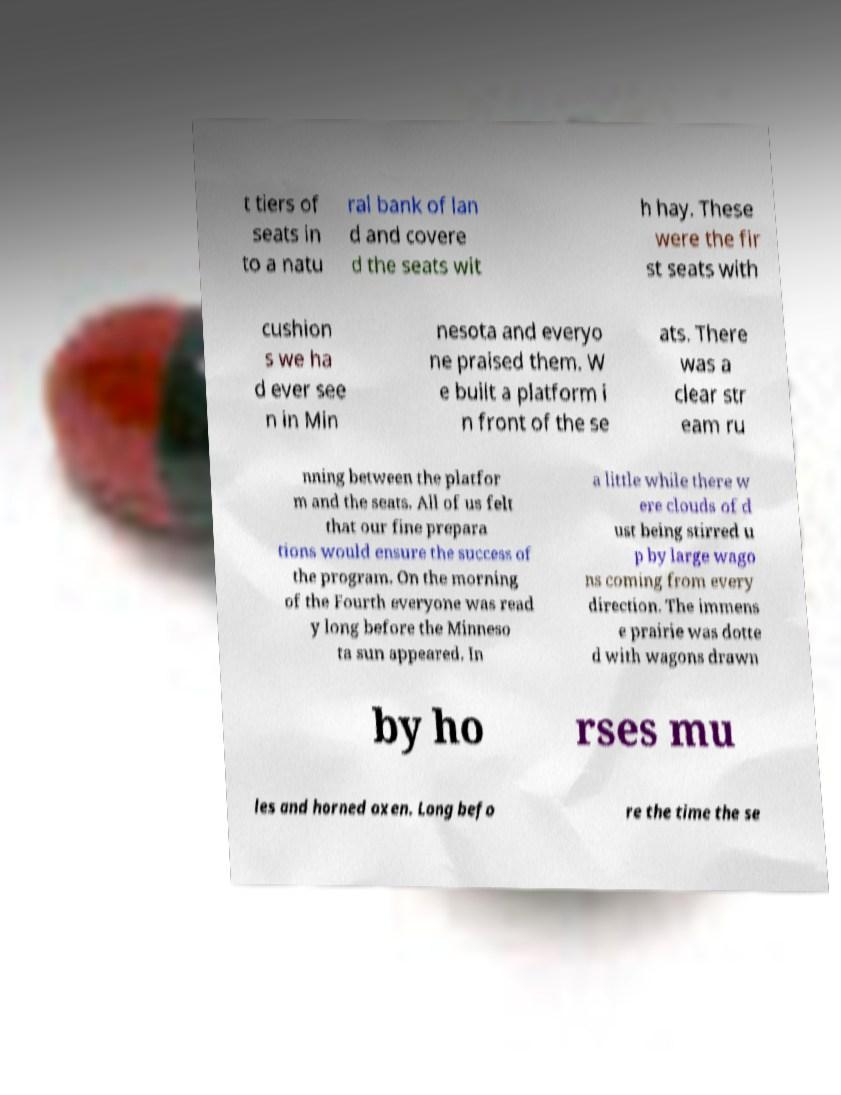I need the written content from this picture converted into text. Can you do that? t tiers of seats in to a natu ral bank of lan d and covere d the seats wit h hay. These were the fir st seats with cushion s we ha d ever see n in Min nesota and everyo ne praised them. W e built a platform i n front of the se ats. There was a clear str eam ru nning between the platfor m and the seats. All of us felt that our fine prepara tions would ensure the success of the program. On the morning of the Fourth everyone was read y long before the Minneso ta sun appeared. In a little while there w ere clouds of d ust being stirred u p by large wago ns coming from every direction. The immens e prairie was dotte d with wagons drawn by ho rses mu les and horned oxen. Long befo re the time the se 